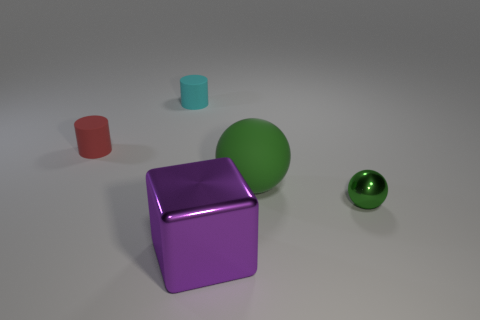Add 1 large purple metal blocks. How many objects exist? 6 Subtract all cubes. How many objects are left? 4 Add 3 rubber spheres. How many rubber spheres are left? 4 Add 3 large cyan metallic things. How many large cyan metallic things exist? 3 Subtract 1 cyan cylinders. How many objects are left? 4 Subtract all small metallic balls. Subtract all small green metallic things. How many objects are left? 3 